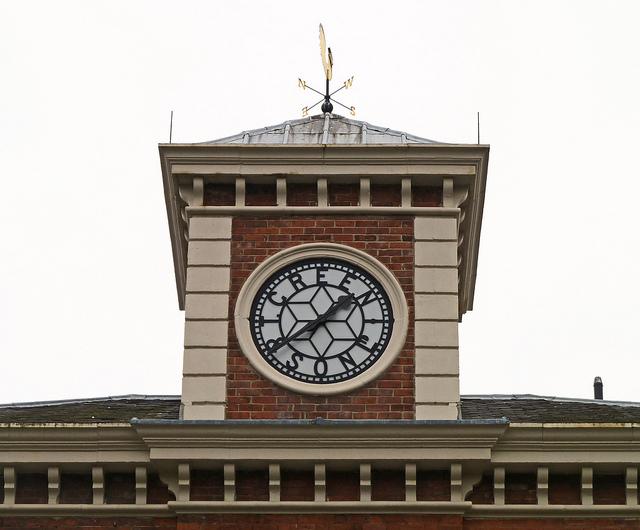Does the clock work?
Answer briefly. Yes. Is the building new?
Quick response, please. No. What is the building made out of?
Be succinct. Brick. What time does the clock say?
Be succinct. 1:40. Is this a Roman clock?
Give a very brief answer. No. 